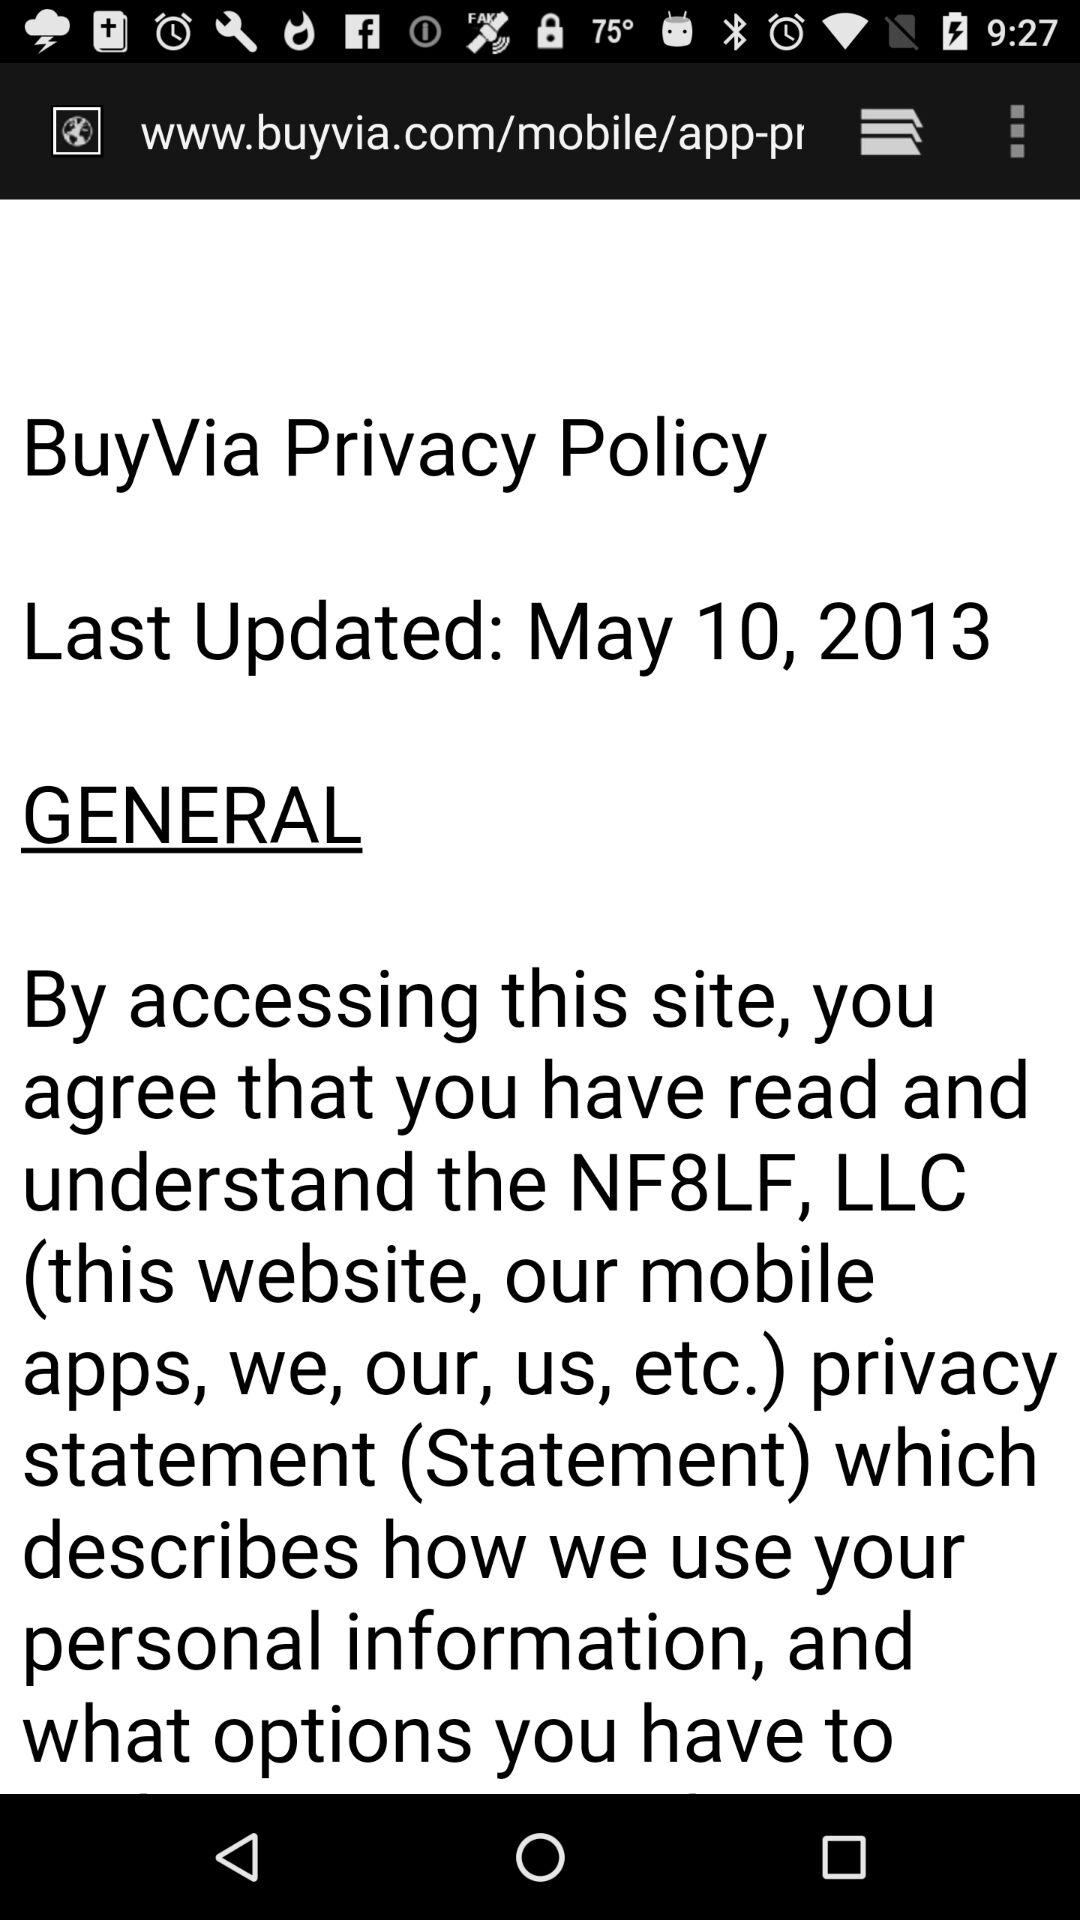On which date was the policy updated? The policy was updated on May 10, 2013. 